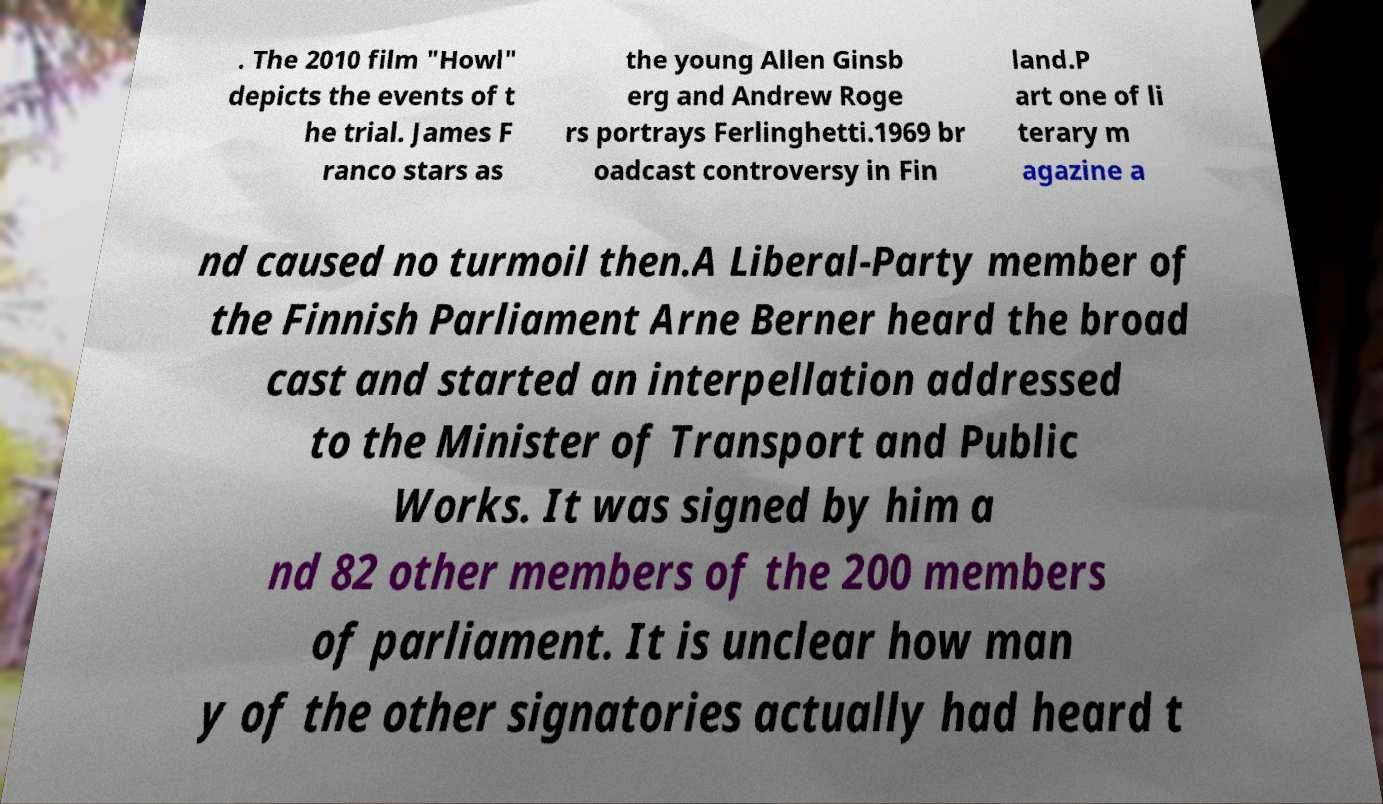For documentation purposes, I need the text within this image transcribed. Could you provide that? . The 2010 film "Howl" depicts the events of t he trial. James F ranco stars as the young Allen Ginsb erg and Andrew Roge rs portrays Ferlinghetti.1969 br oadcast controversy in Fin land.P art one of li terary m agazine a nd caused no turmoil then.A Liberal-Party member of the Finnish Parliament Arne Berner heard the broad cast and started an interpellation addressed to the Minister of Transport and Public Works. It was signed by him a nd 82 other members of the 200 members of parliament. It is unclear how man y of the other signatories actually had heard t 